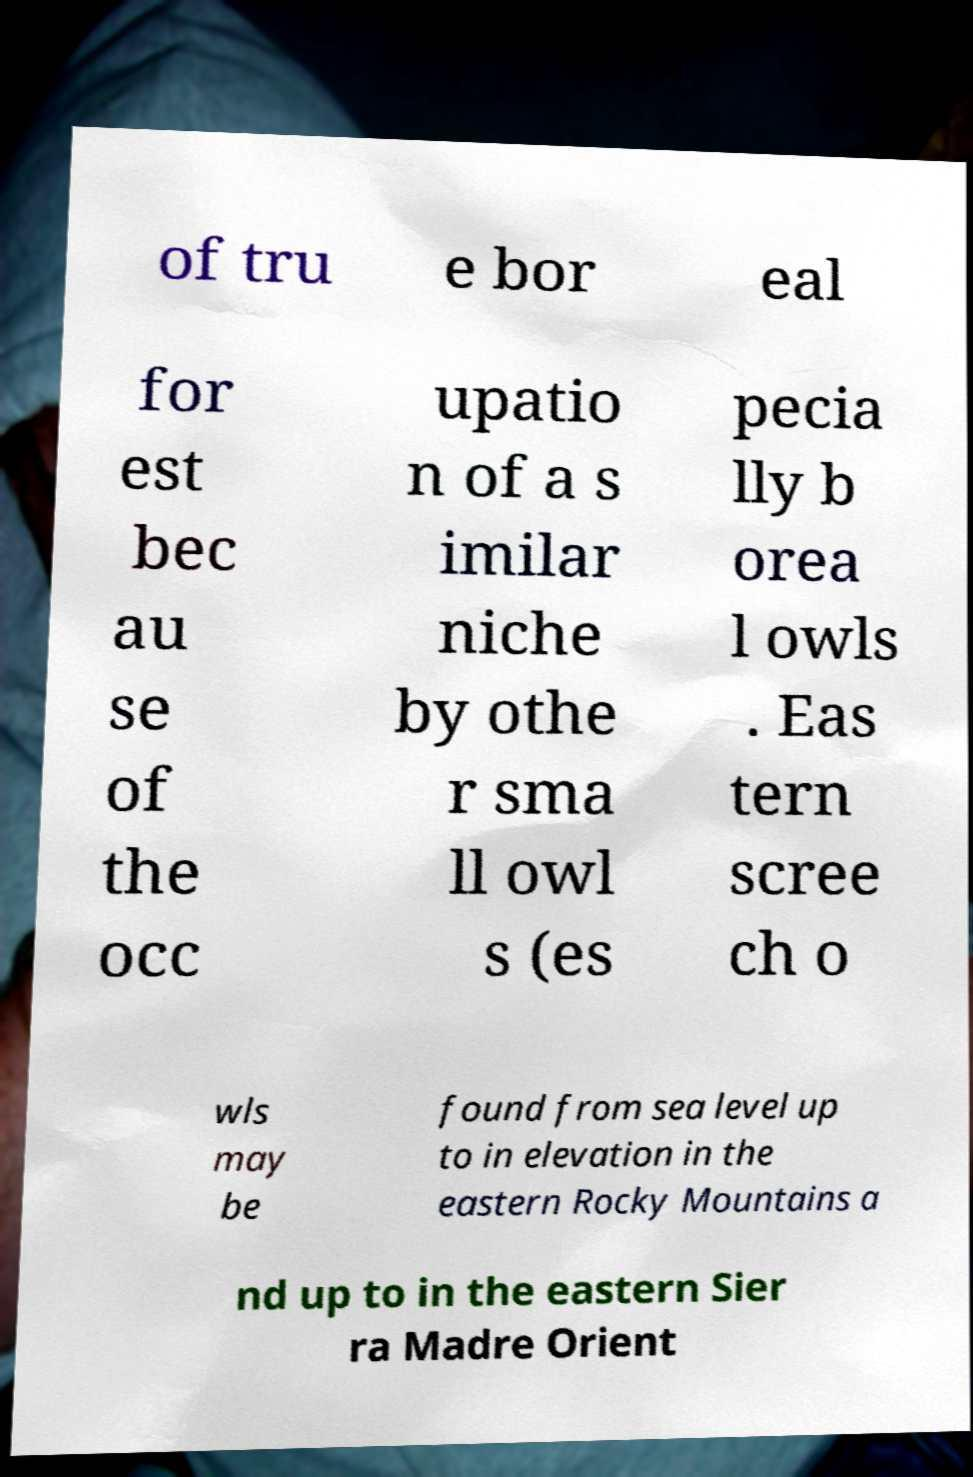What messages or text are displayed in this image? I need them in a readable, typed format. of tru e bor eal for est bec au se of the occ upatio n of a s imilar niche by othe r sma ll owl s (es pecia lly b orea l owls . Eas tern scree ch o wls may be found from sea level up to in elevation in the eastern Rocky Mountains a nd up to in the eastern Sier ra Madre Orient 